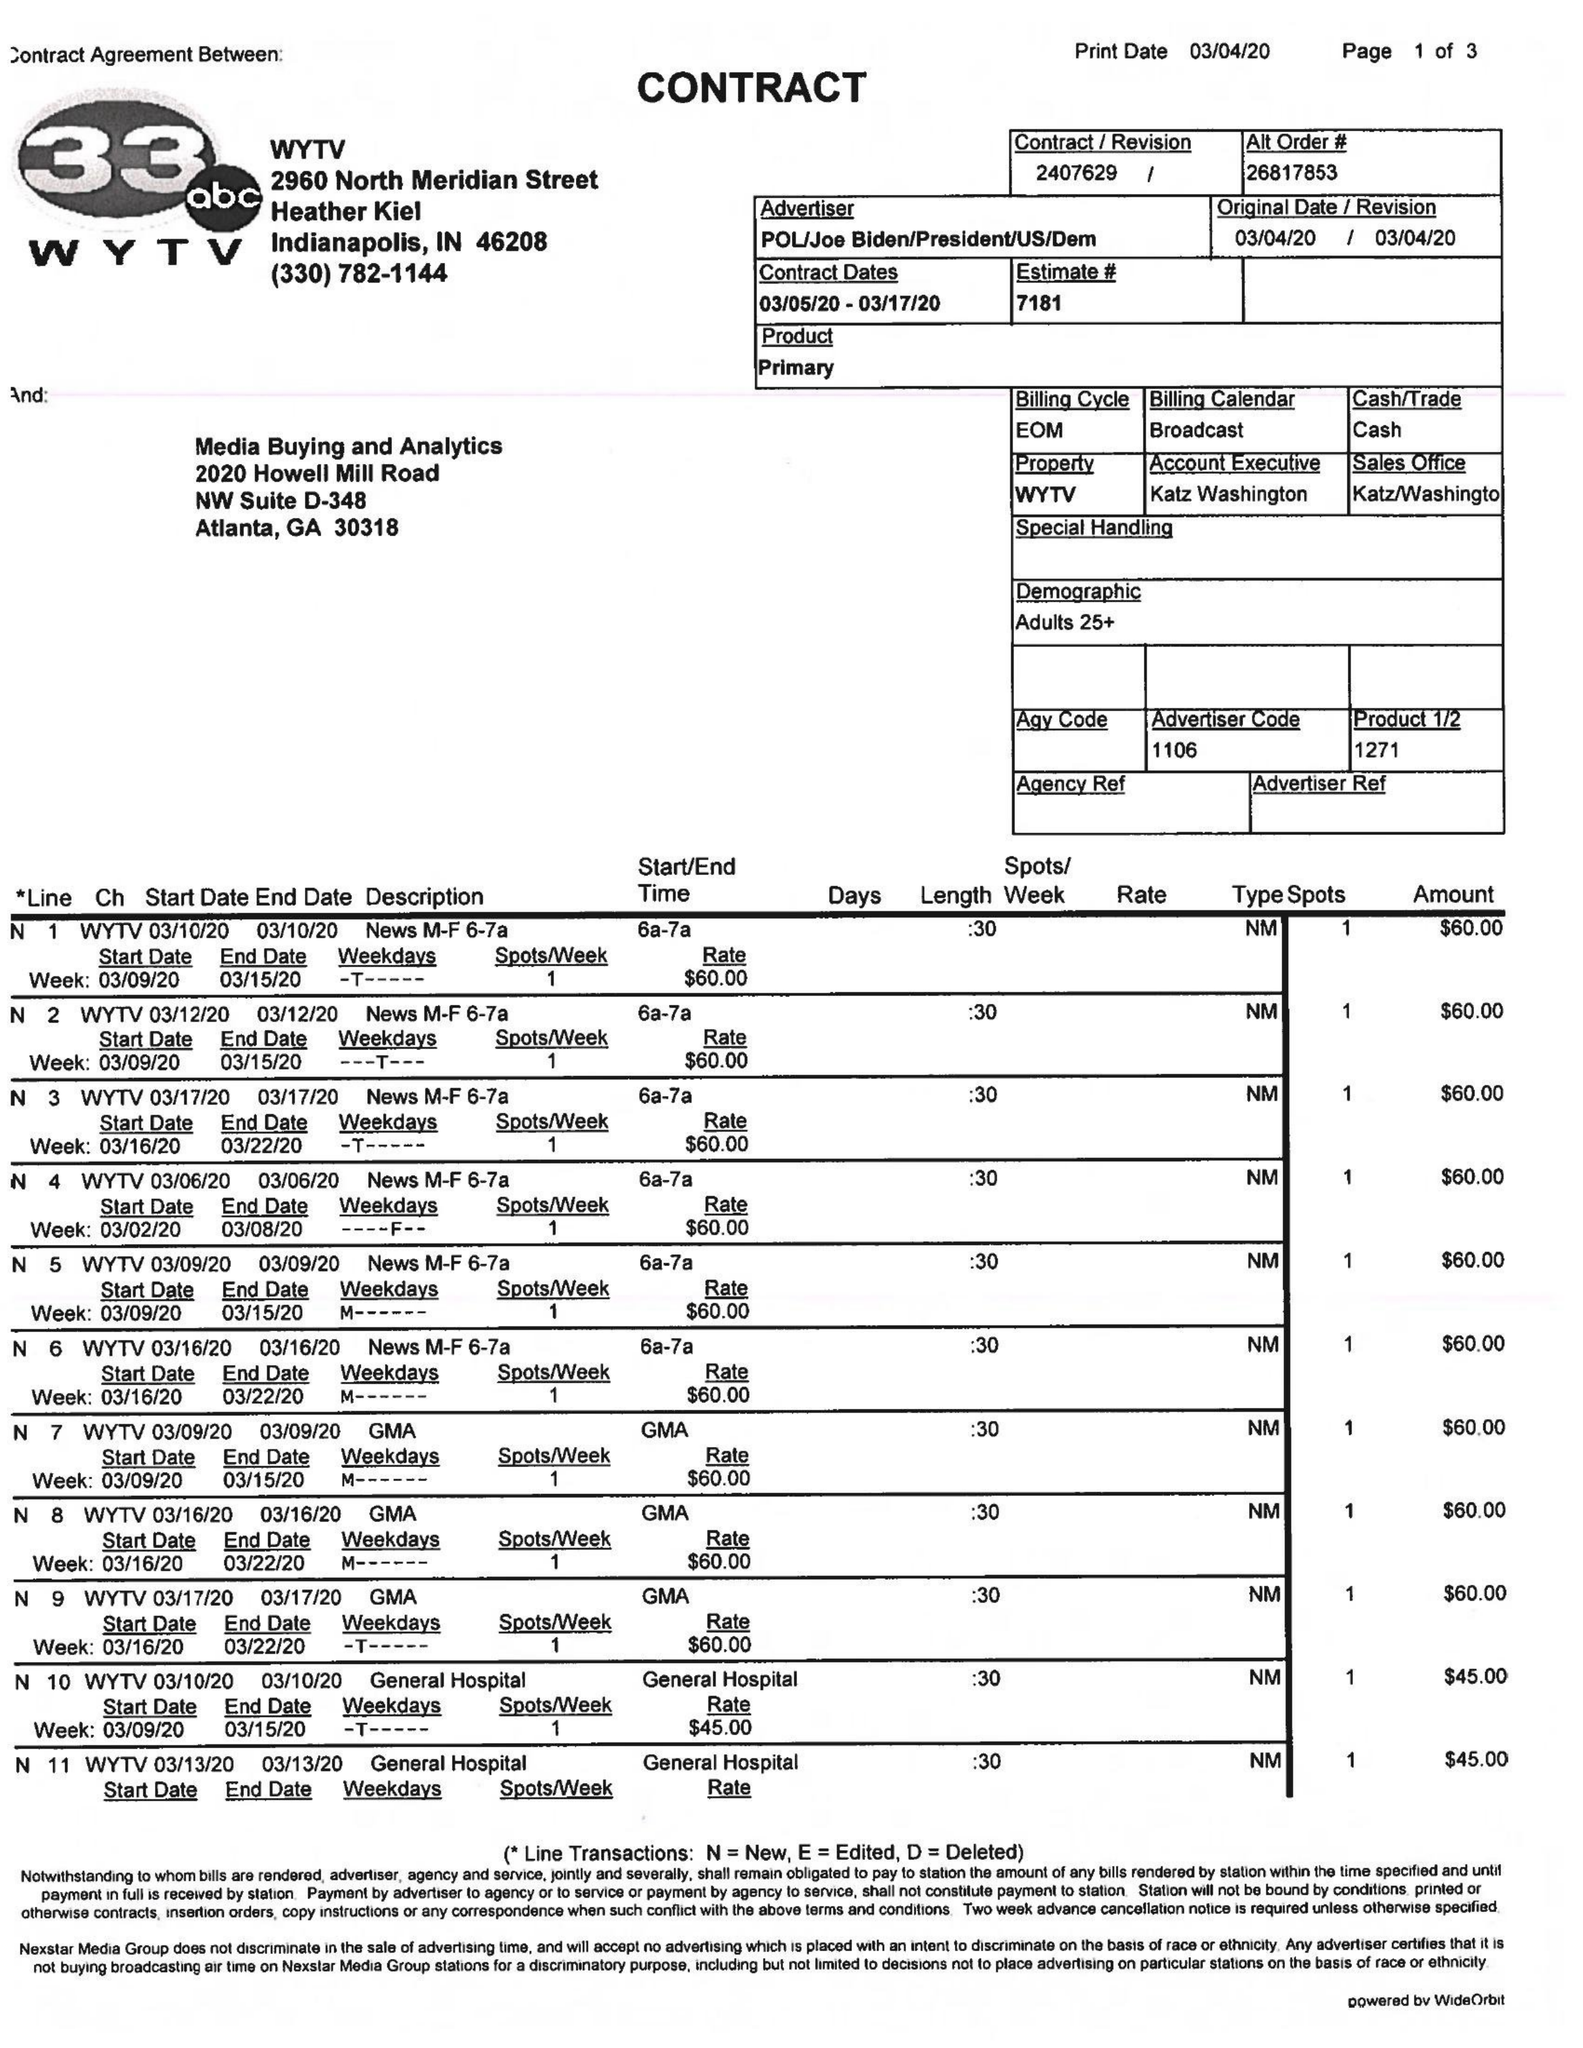What is the value for the gross_amount?
Answer the question using a single word or phrase. 2530.00 